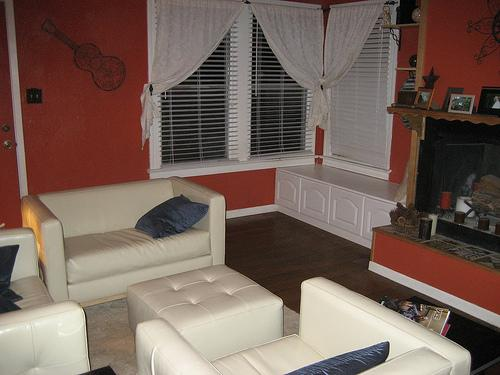What is the color of the pillow and its position in the room? The pillow is blue and can be found on the white leather love seat. What are the colors of the walls and the floors in the image? The walls have a red color, and the wooden floors are dark brown. Mention a specific piece of furniture present in the living room. A white leather love seat with a blue pillow is placed in the living room. List any visible items on top of a table or a surface. Some magazines can be found on a side table and a bowl of pinecones is displayed as well. Describe the fireplace and its surroundings. The fireplace is in the living room, has a tile mantle, and several picture frames are displayed on the shelf above it. Describe any artwork or decoration found on the wall. There is a guitar-shaped wall art and a wall decoration shaped like a guitar found on the wall. Identify a piece of upholstered furniture and the material it is made of. The love seat is made of white leather, giving it an elegant look. What kind of seat can be found in the image and its features? A white window seat is located under the window, and it provides a cozy spot to enjoy the view. How many curtains are there, and what is their color? There are three white curtains hanging by the windows. What is the color of the curtains and the window covering, and what is found beneath the window? The curtains are white, the blinds are miniblinds, and there's a white built-in cabinet under the window. 